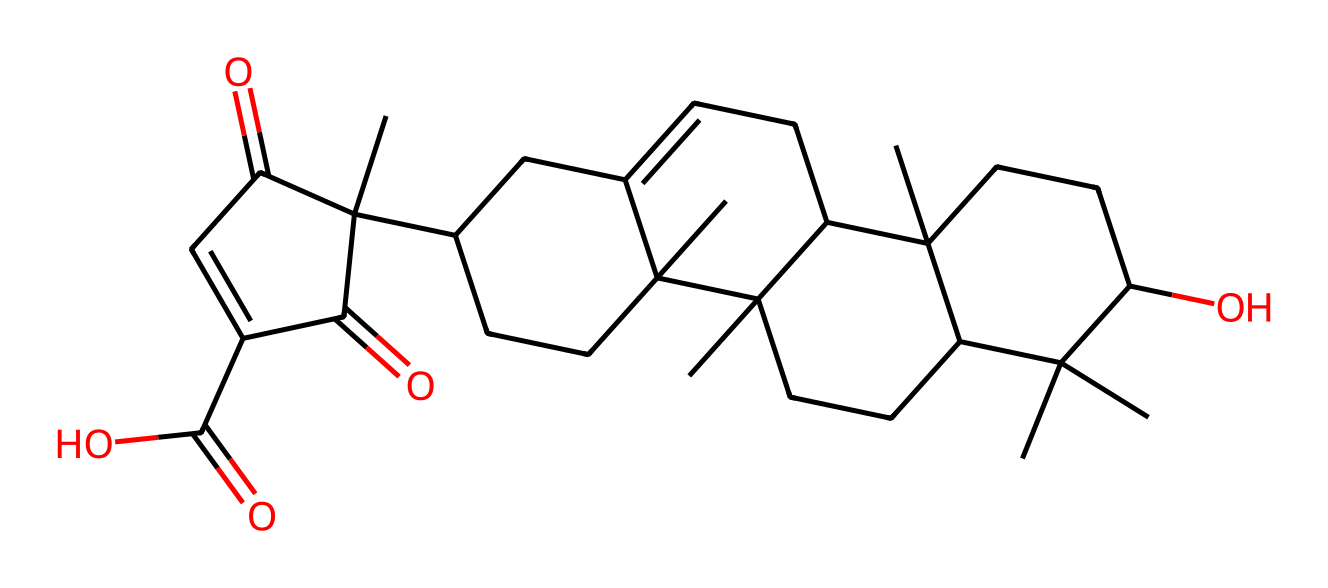What is the molecular formula of this compound? To determine the molecular formula, you need to count the types and numbers of atoms present in the structure represented by the SMILES notation. The chemical consists of carbon (C), hydrogen (H), and oxygen (O) atoms. Counting gives us C30, H50, and O4, leading us to the formula C30H50O4.
Answer: C30H50O4 How many rings are present in the structure? By analyzing the structure derived from the SMILES representation, we identify regions in the compound that form closed loops or cycles. This compound contains four distinct rings based on the connectivity of carbon atoms. Therefore, the final count gives us four rings in total.
Answer: 4 What is the functional group present in this compound? A functional group is a specific group of atoms that imparts distinct properties to a molecule. In this case, by examining the composition, we find that the compound contains a carboxylic acid functional group (due to the presence of C(=O)O) alongside rings and hydroxyl (-OH) groups. The presence of the carboxylic group makes it unique.
Answer: carboxylic acid Is this compound a saturated or unsaturated terpene? By evaluating the structure's bonding, we can distinguish between saturated and unsaturated compounds. Unsaturated compounds contain double bonds or rings, evident in this compound due to the presence of multiple carbon-carbon double bonds and rings. Thus, the compound is classified as unsaturated.
Answer: unsaturated How many stereocenters does this structure possess? A stereocenter is a carbon atom that has four different substituents attached. Analyzing the structure shows that there are several carbon atoms bonded to different groups. When counting, it is found that there are four stereocenters located in the arms of the molecule, leading to the identification of four such centers.
Answer: 4 What type of aromatic compound does frankincense belong to? Frankincense, represented by this chemical structure, falls under the category of terpenes, specifically boswellic acids due to its structure that is primarily composed of terpenoid skeletons known for their aromatic qualities. This chemical is identified as a sesquiterpene.
Answer: sesquiterpene 